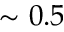<formula> <loc_0><loc_0><loc_500><loc_500>\sim 0 . 5</formula> 